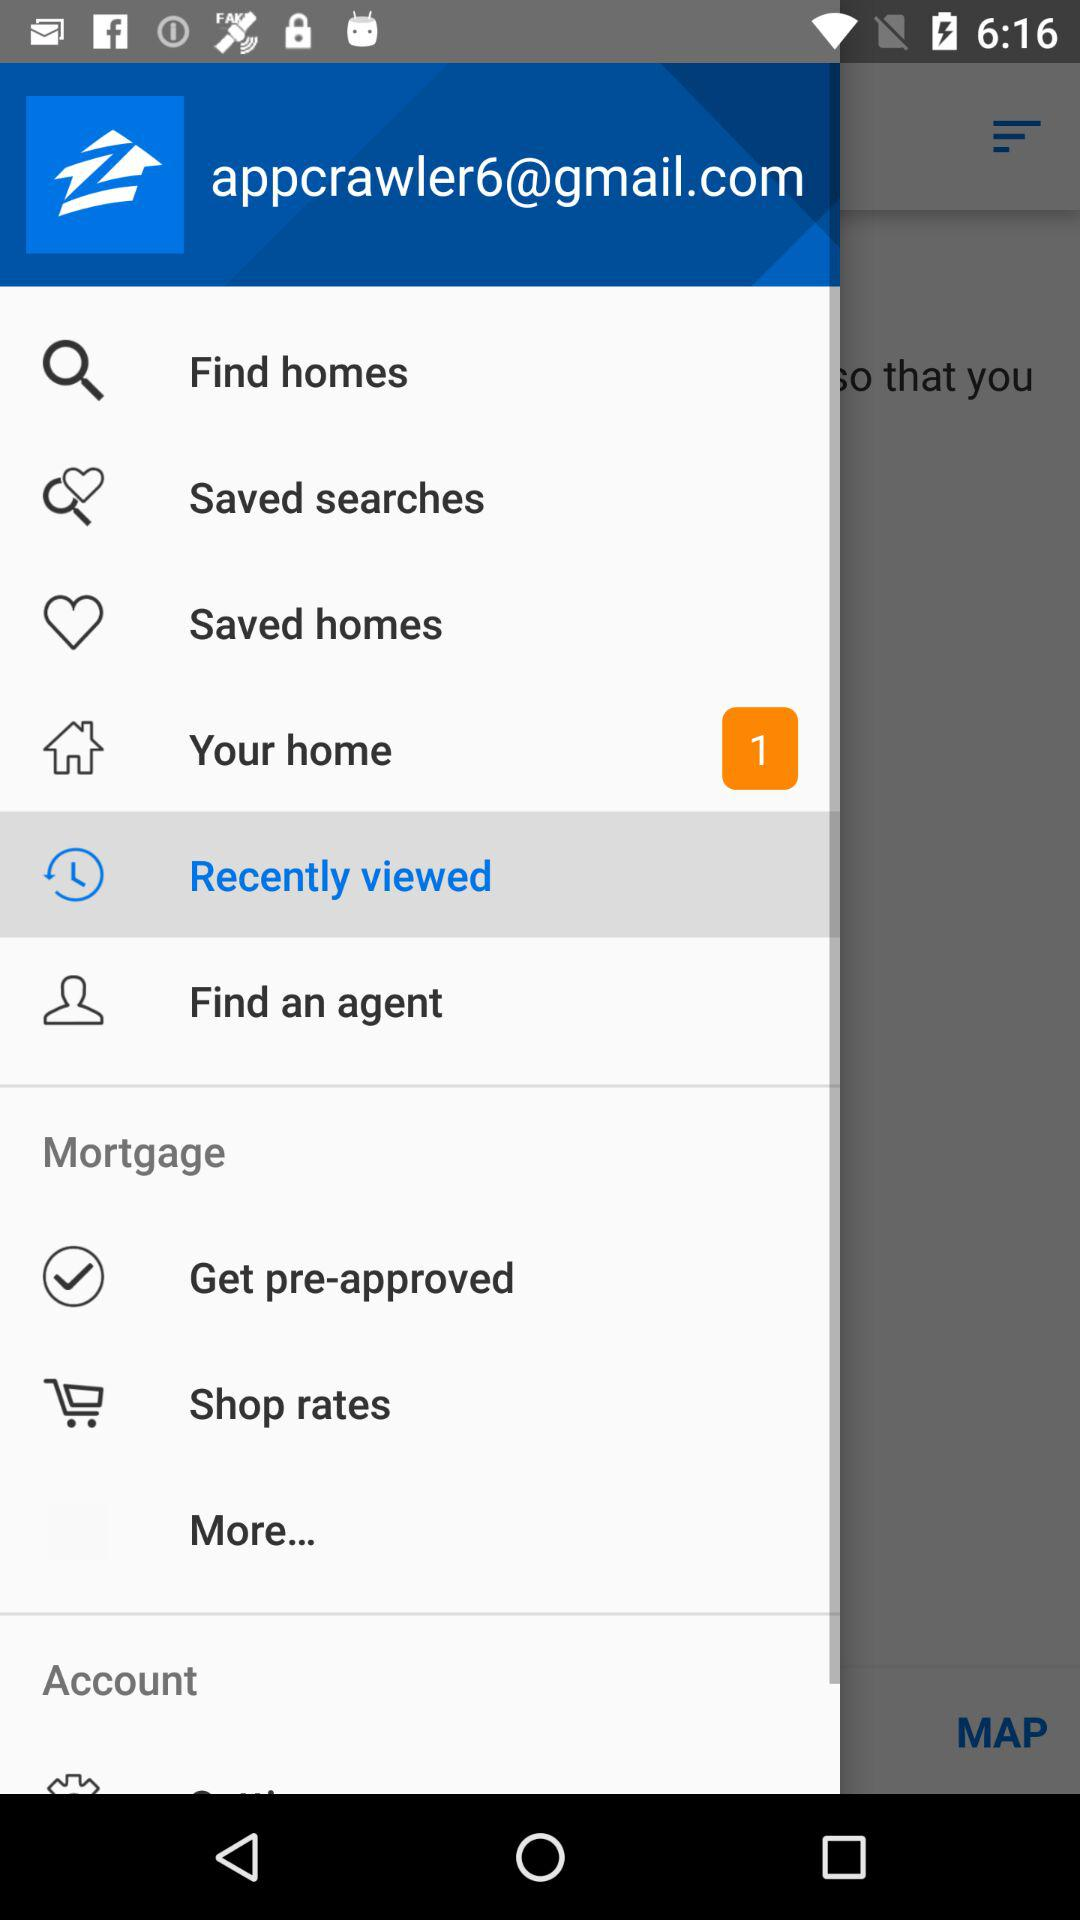How many new notifications have you received on your home option? There is 1 new notification received. 